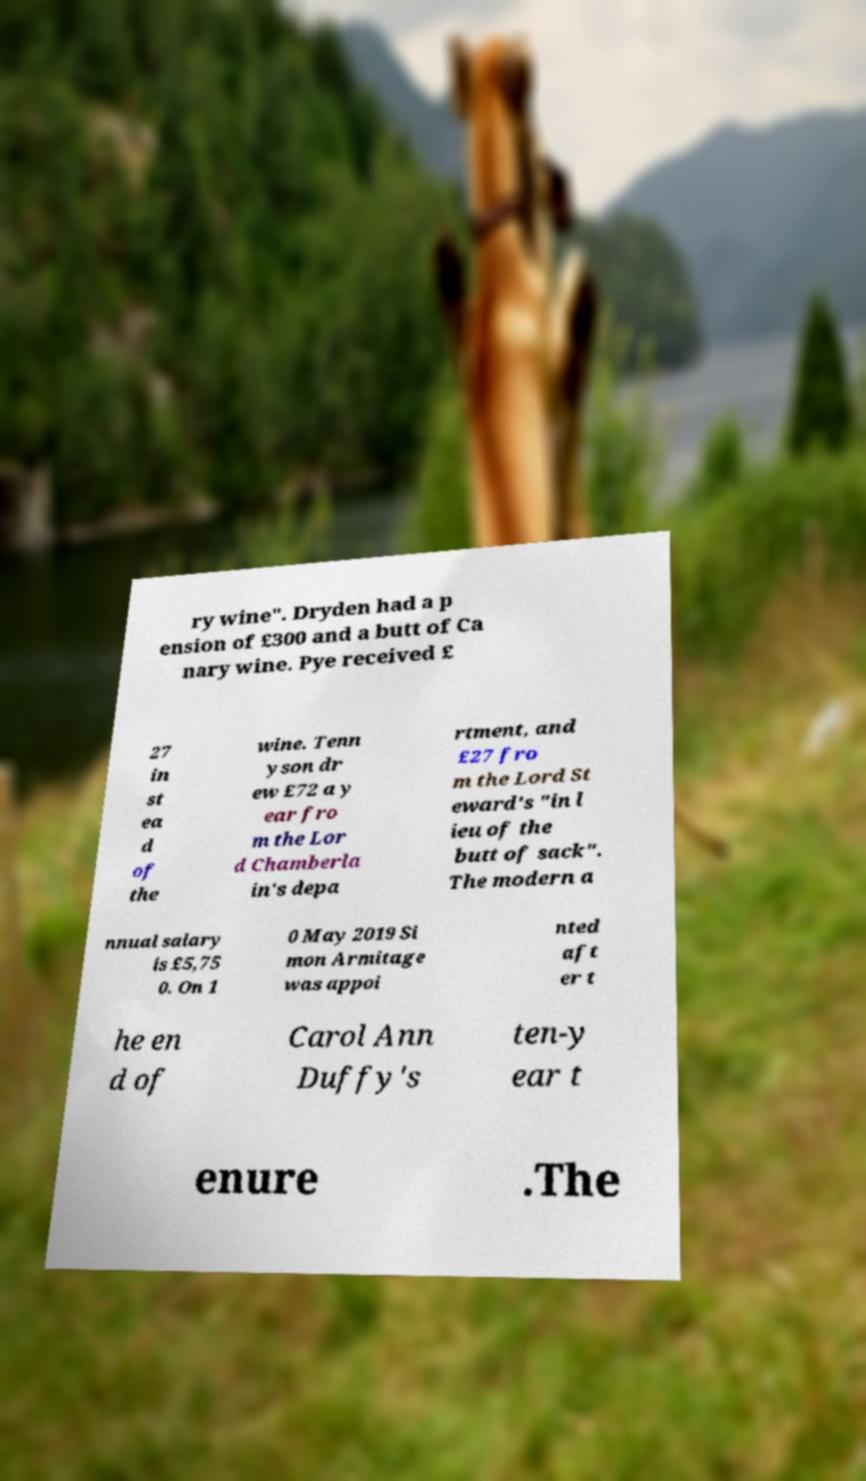Could you extract and type out the text from this image? ry wine". Dryden had a p ension of £300 and a butt of Ca nary wine. Pye received £ 27 in st ea d of the wine. Tenn yson dr ew £72 a y ear fro m the Lor d Chamberla in's depa rtment, and £27 fro m the Lord St eward's "in l ieu of the butt of sack". The modern a nnual salary is £5,75 0. On 1 0 May 2019 Si mon Armitage was appoi nted aft er t he en d of Carol Ann Duffy's ten-y ear t enure .The 